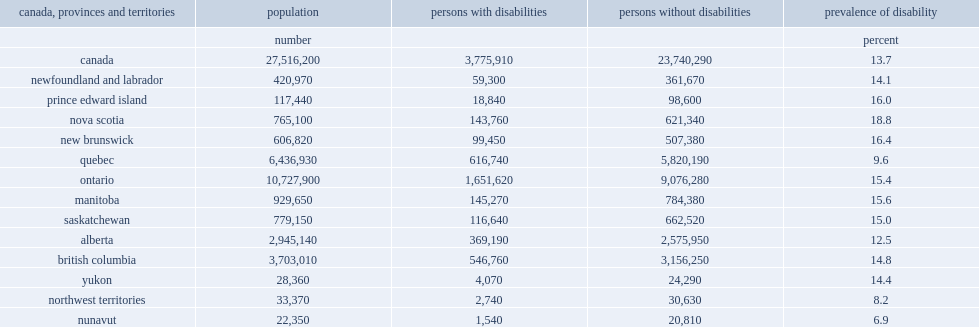What was the prevalence of disability in quebec? 9.6. What was the prevalence of disability in nova scotia? 18.8. Which province has the highest prevalence of disabilities in canada? Nova scotia. What was the prevalence of disability in yukon? 14.4. What was the prevalence of disability in northwest territories? 8.2. What was the prevalence of disability in nunavut? 6.9. 